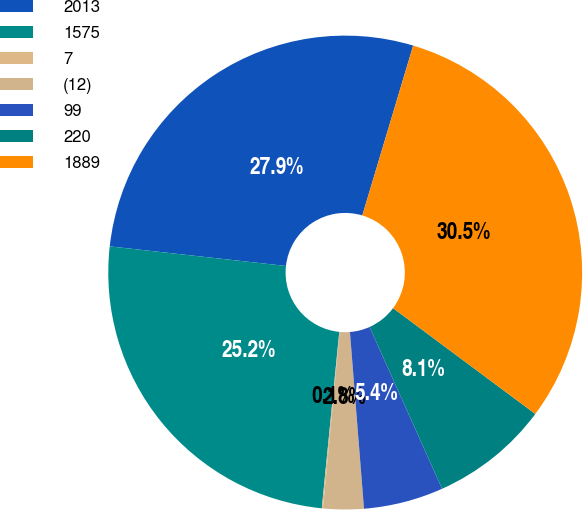Convert chart. <chart><loc_0><loc_0><loc_500><loc_500><pie_chart><fcel>2013<fcel>1575<fcel>7<fcel>(12)<fcel>99<fcel>220<fcel>1889<nl><fcel>27.87%<fcel>25.19%<fcel>0.08%<fcel>2.76%<fcel>5.44%<fcel>8.12%<fcel>30.55%<nl></chart> 